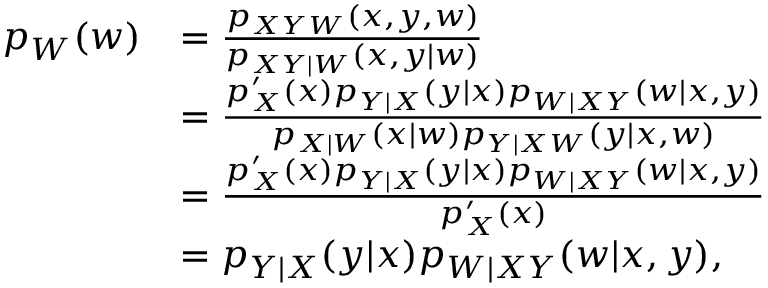Convert formula to latex. <formula><loc_0><loc_0><loc_500><loc_500>\begin{array} { r l } { p _ { W } ( w ) } & { = \frac { p _ { X Y W } ( x , y , w ) } { p _ { X Y | W } ( x , y | w ) } } \\ & { = \frac { p _ { X } ^ { \prime } ( x ) p _ { Y | X } ( y | x ) p _ { W | X Y } ( w | x , y ) } { p _ { X | W } ( x | w ) p _ { Y | X W } ( y | x , w ) } } \\ & { = \frac { p _ { X } ^ { \prime } ( x ) p _ { Y | X } ( y | x ) p _ { W | X Y } ( w | x , y ) } { p _ { X } ^ { \prime } ( x ) } } \\ & { = p _ { Y | X } ( y | x ) p _ { W | X Y } ( w | x , y ) , } \end{array}</formula> 